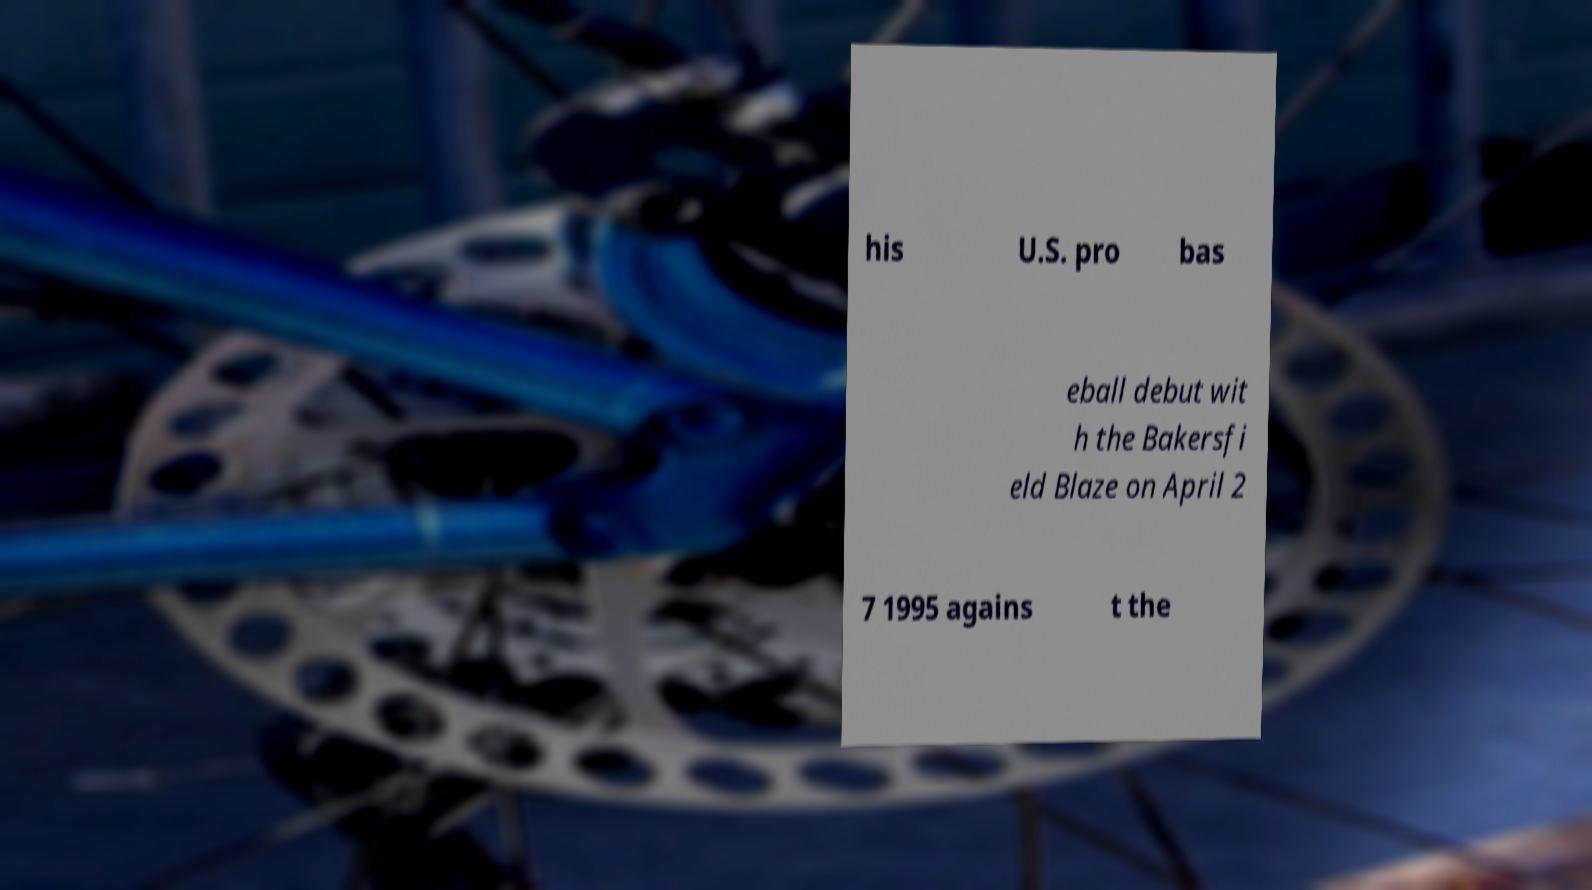There's text embedded in this image that I need extracted. Can you transcribe it verbatim? his U.S. pro bas eball debut wit h the Bakersfi eld Blaze on April 2 7 1995 agains t the 